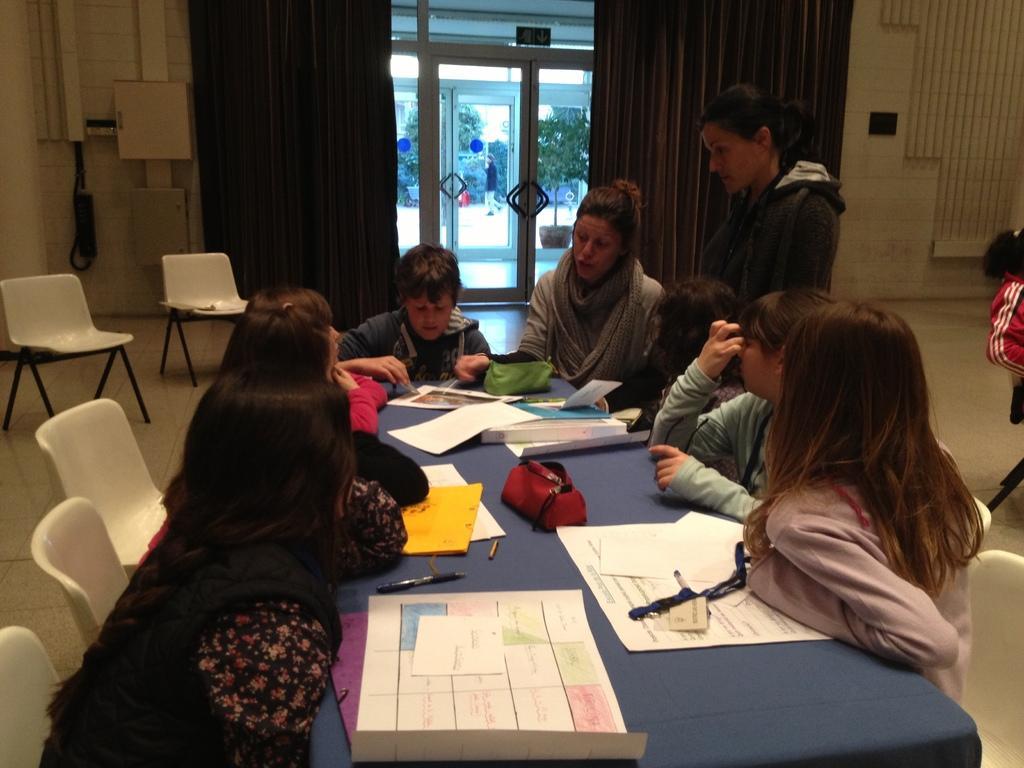Please provide a concise description of this image. In the image I can see people are sitting on chairs in front of table. On the table I can see papers, books, charts and some other objects. The woman on the right side of the image is standing on the floor. In the background I can see a white color chairs, curtains, a glass door, wall, trees and other objects. 